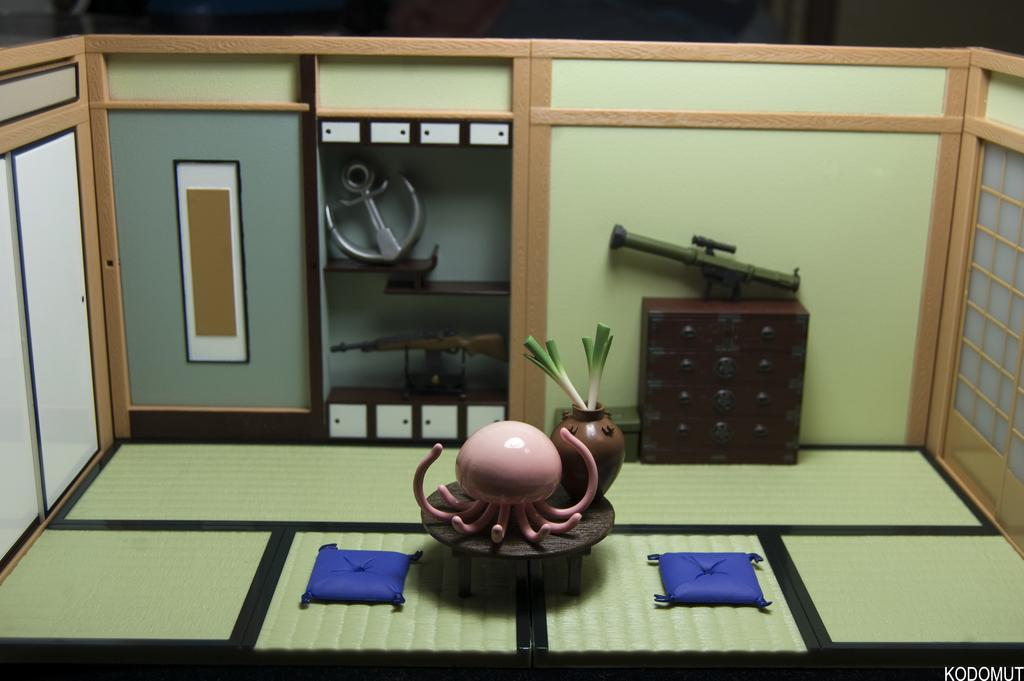What type of vehicle or equipment is present in the image? There is a rocket launcher in the image. What other object can be seen in the image? There is an anchor in the image. What type of weapon is visible in the image? There is a weapon in the image. How many chickens are present in the image? There are no chickens present in the image. What type of bedding is visible in the image? There is no bedding present in the image. 